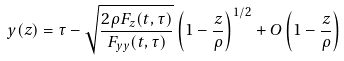<formula> <loc_0><loc_0><loc_500><loc_500>y ( z ) & = \tau - \sqrt { \frac { 2 \rho F _ { z } ( t , \tau ) } { F _ { y y } ( t , \tau ) } } \left ( 1 - \frac { z } { \rho } \right ) ^ { 1 / 2 } + O \left ( 1 - \frac { z } { \rho } \right )</formula> 